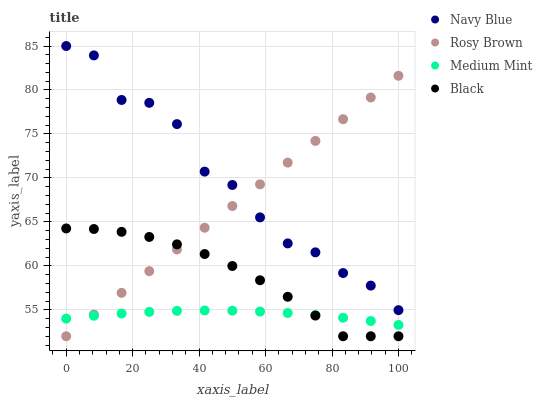Does Medium Mint have the minimum area under the curve?
Answer yes or no. Yes. Does Navy Blue have the maximum area under the curve?
Answer yes or no. Yes. Does Rosy Brown have the minimum area under the curve?
Answer yes or no. No. Does Rosy Brown have the maximum area under the curve?
Answer yes or no. No. Is Rosy Brown the smoothest?
Answer yes or no. Yes. Is Navy Blue the roughest?
Answer yes or no. Yes. Is Navy Blue the smoothest?
Answer yes or no. No. Is Rosy Brown the roughest?
Answer yes or no. No. Does Rosy Brown have the lowest value?
Answer yes or no. Yes. Does Navy Blue have the lowest value?
Answer yes or no. No. Does Navy Blue have the highest value?
Answer yes or no. Yes. Does Rosy Brown have the highest value?
Answer yes or no. No. Is Medium Mint less than Navy Blue?
Answer yes or no. Yes. Is Navy Blue greater than Black?
Answer yes or no. Yes. Does Black intersect Rosy Brown?
Answer yes or no. Yes. Is Black less than Rosy Brown?
Answer yes or no. No. Is Black greater than Rosy Brown?
Answer yes or no. No. Does Medium Mint intersect Navy Blue?
Answer yes or no. No. 